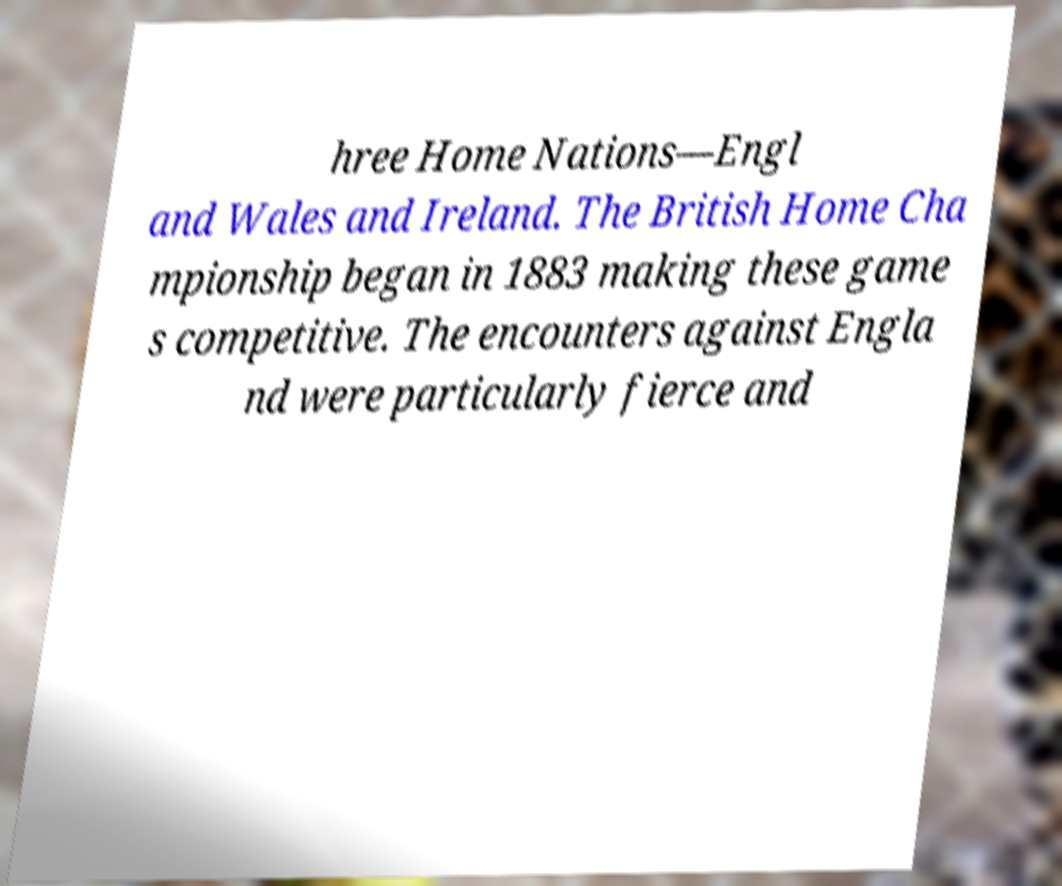I need the written content from this picture converted into text. Can you do that? hree Home Nations—Engl and Wales and Ireland. The British Home Cha mpionship began in 1883 making these game s competitive. The encounters against Engla nd were particularly fierce and 